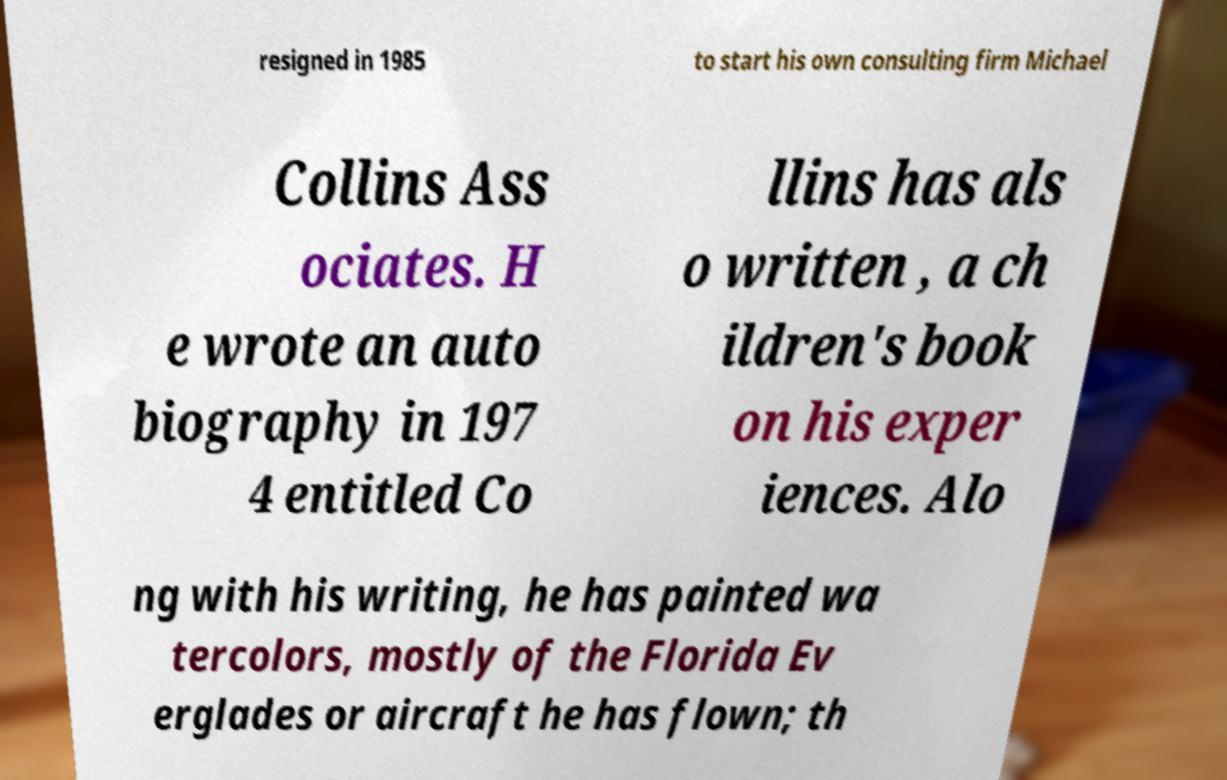Please identify and transcribe the text found in this image. resigned in 1985 to start his own consulting firm Michael Collins Ass ociates. H e wrote an auto biography in 197 4 entitled Co llins has als o written , a ch ildren's book on his exper iences. Alo ng with his writing, he has painted wa tercolors, mostly of the Florida Ev erglades or aircraft he has flown; th 